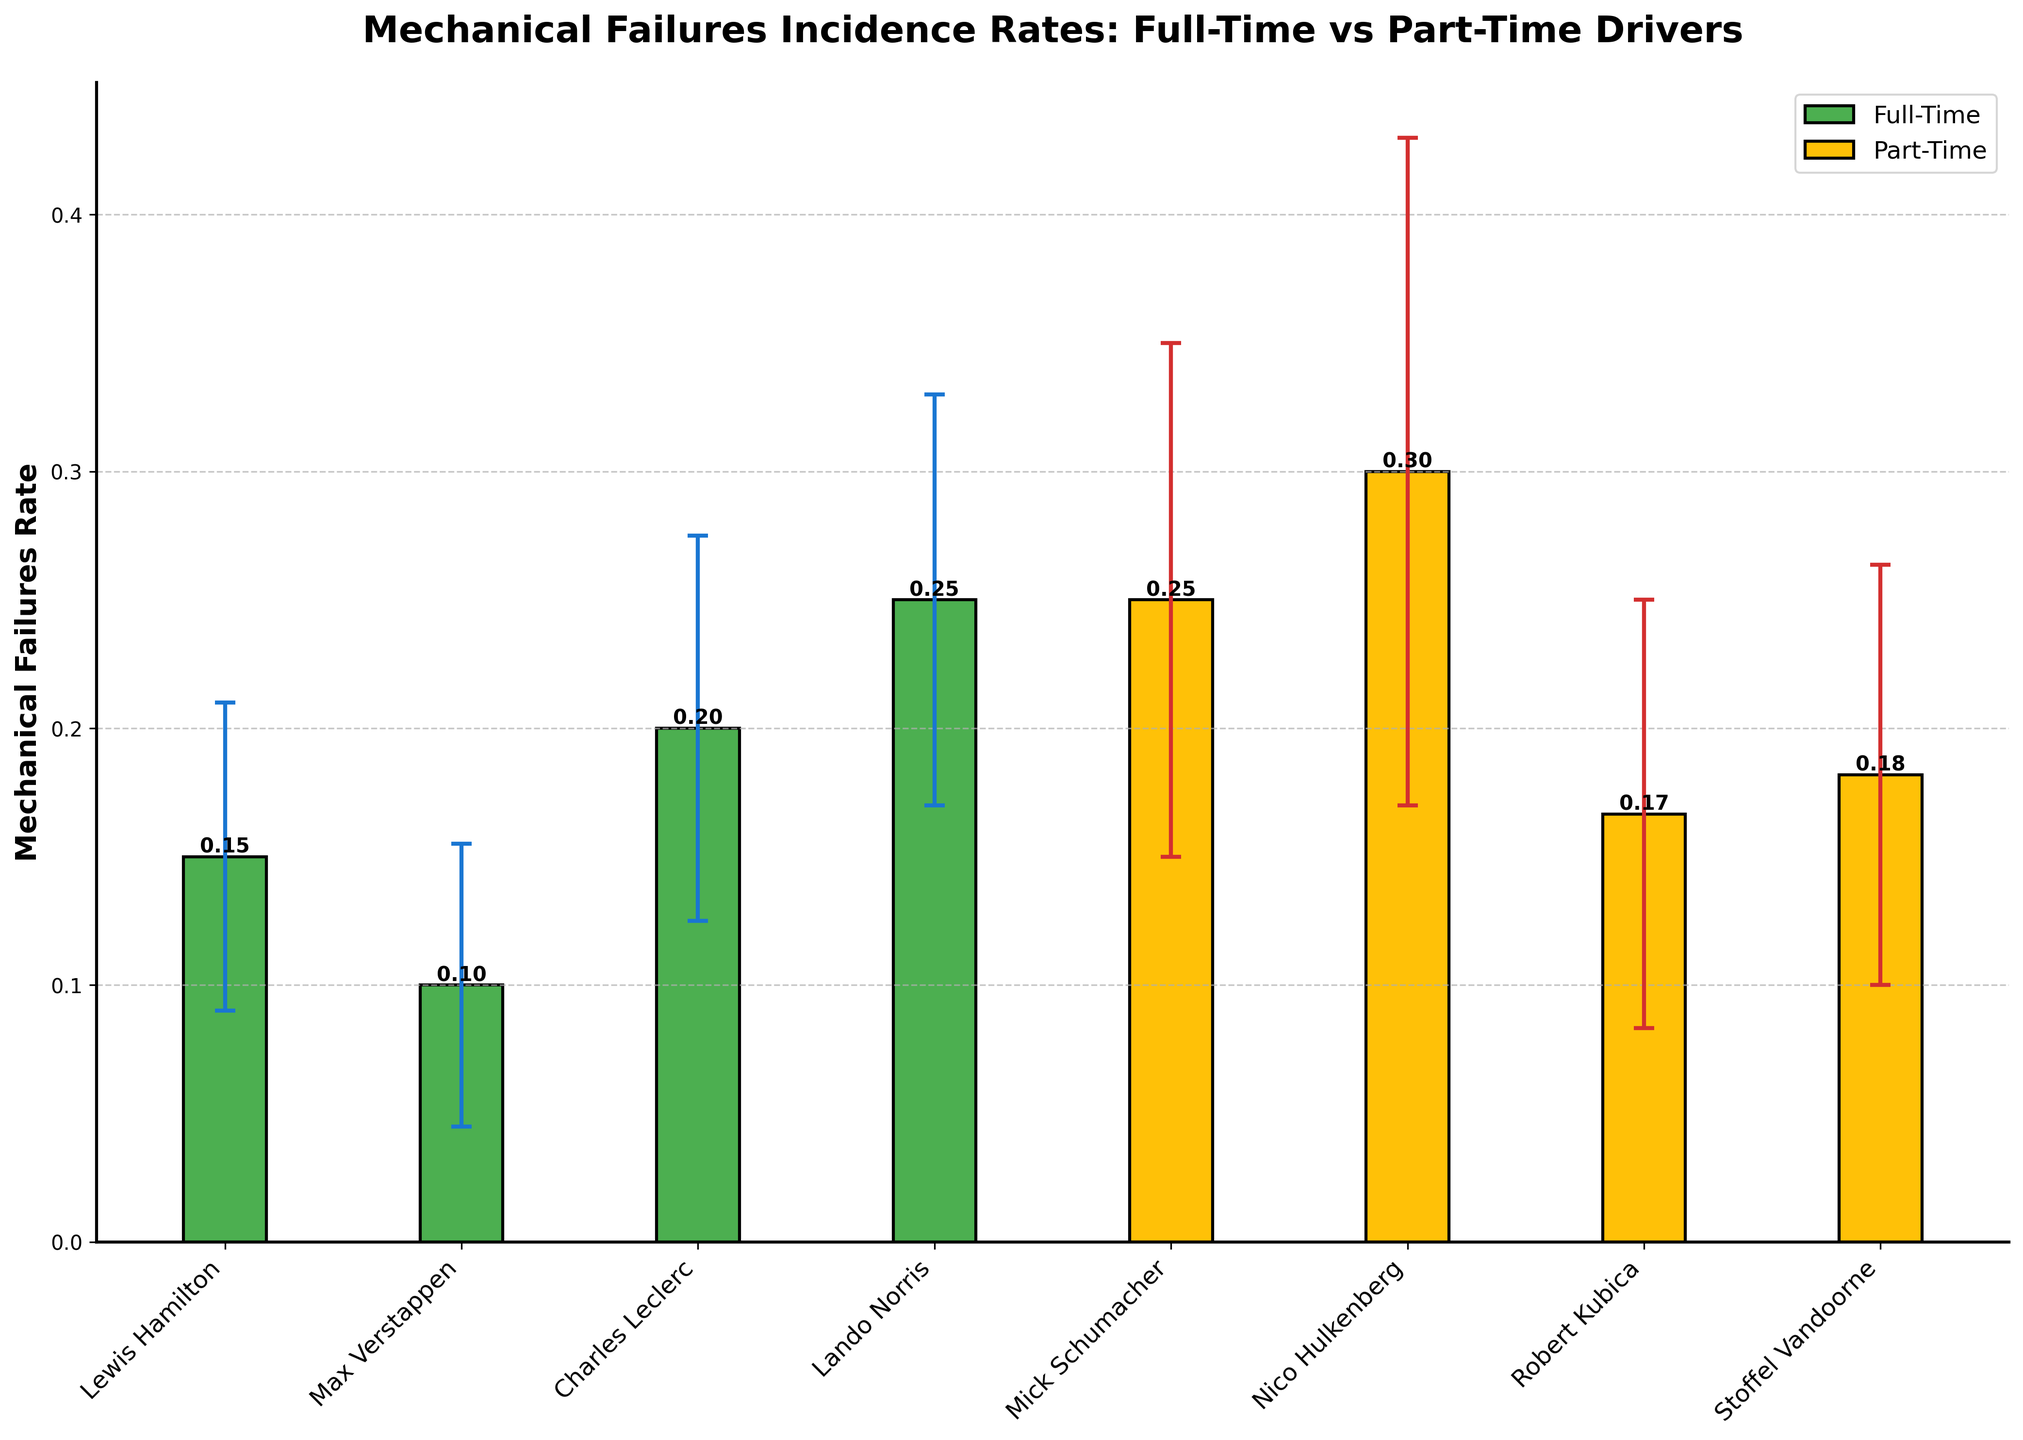What is the title of the figure? The title usually appears at the top of the figure in large, bold text. It succinctly describes what the plot is about. In this case, the title states that the plot shows the mechanical failures incidence rates for full-time versus part-time drivers.
Answer: Mechanical Failures Incidence Rates: Full-Time vs Part-Time Drivers How many part-time drivers are shown in the plot? By counting the distinct bars within the section labeled for part-time drivers, you can determine the number of part-time drivers. Each bar represents one driver.
Answer: 4 Which driver has the highest mechanical failures rate? To identify the driver with the highest mechanical failures rate, visually compare the heights of all bars in the plot. The tallest bar represents the driver with the highest rate.
Answer: Lando Norris What is the mechanical failures rate for Nico Hulkenberg? Locate the bar representing Nico Hulkenberg within the part-time drivers section and read the height of this bar, which is also likely annotated with the exact rate value.
Answer: 0.30 Which group of drivers, full-time or part-time, has a higher average mechanical failures rate? To find this, calculate the mean values of the mechanical failures rates for both groups by summing the rates of each driver in the respective group and dividing by the number of drivers in that group. Compare these mean values. Since the visual plot indicates that the full-time drivers have a higher collective sum in rates, their average is higher.
Answer: Full-Time Is there overlap in the mechanical failures rates between full-time and part-time drivers? By checking the error bars, which indicate the range within the standard deviation, see if any part-time driver's error bar range overlaps with any full-time driver's range. This can infer if there's statistical overlap.
Answer: Yes Who has the lowest mechanical failures rate among all drivers? Identify the shortest bar in the entire plot, which represents the driver with the lowest mechanical failures rate. This shortest bar indicates the minimum rate.
Answer: Robert Kubica What is the total mechanical failures rate for all full-time drivers combined? Sum up the mechanical failures rates for all full-time drivers directly from the height of the bars representing these drivers.
Answer: 0.15 How does the variability in mechanical failures rates compare between full-time and part-time drivers? Examine the length of the error bars for both groups of drivers. Longer error bars indicate greater variability in the mechanical failure rates. Compare the general lengths of error bars between the two groups.
Answer: Part-Time drivers show more variability What is the average mechanical failures rate for part-time drivers? Calculate the sum of the failures rates for all part-time drivers and then divide by the number of part-time drivers. Rates: (0.25 + 0.30 + 0.17 + 0.18), Average = (0.25 + 0.30 + 0.17 + 0.18) / 4 = 0.225
Answer: 0.225 